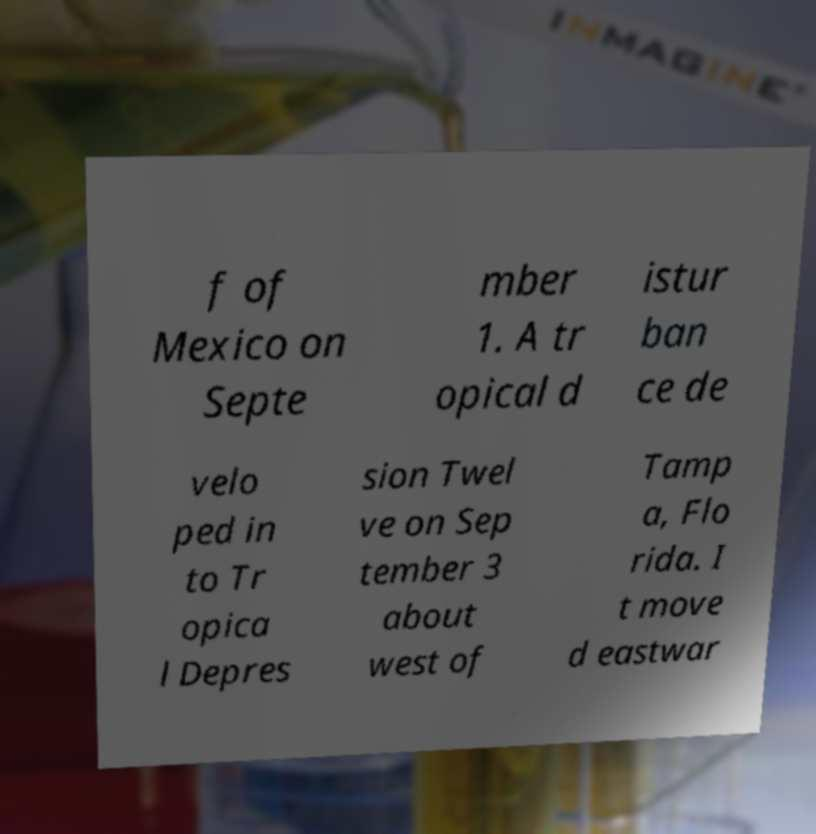Please read and relay the text visible in this image. What does it say? f of Mexico on Septe mber 1. A tr opical d istur ban ce de velo ped in to Tr opica l Depres sion Twel ve on Sep tember 3 about west of Tamp a, Flo rida. I t move d eastwar 